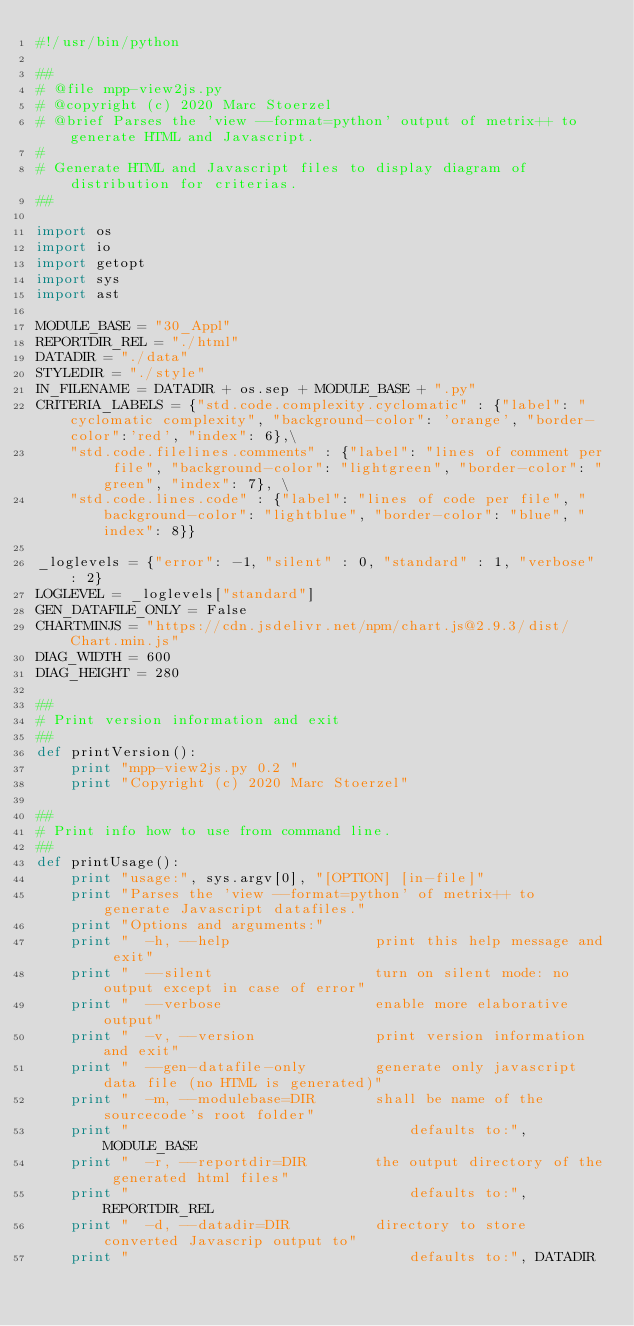Convert code to text. <code><loc_0><loc_0><loc_500><loc_500><_Python_>#!/usr/bin/python

##
# @file mpp-view2js.py
# @copyright (c) 2020 Marc Stoerzel
# @brief Parses the 'view --format=python' output of metrix++ to generate HTML and Javascript.
#
# Generate HTML and Javascript files to display diagram of distribution for criterias.
##

import os
import io
import getopt
import sys
import ast

MODULE_BASE = "30_Appl"
REPORTDIR_REL = "./html"
DATADIR = "./data"
STYLEDIR = "./style"
IN_FILENAME = DATADIR + os.sep + MODULE_BASE + ".py"
CRITERIA_LABELS = {"std.code.complexity.cyclomatic" : {"label": "cyclomatic complexity", "background-color": 'orange', "border-color":'red', "index": 6},\
    "std.code.filelines.comments" : {"label": "lines of comment per file", "background-color": "lightgreen", "border-color": "green", "index": 7}, \
    "std.code.lines.code" : {"label": "lines of code per file", "background-color": "lightblue", "border-color": "blue", "index": 8}}

_loglevels = {"error": -1, "silent" : 0, "standard" : 1, "verbose" : 2}
LOGLEVEL = _loglevels["standard"]
GEN_DATAFILE_ONLY = False
CHARTMINJS = "https://cdn.jsdelivr.net/npm/chart.js@2.9.3/dist/Chart.min.js"
DIAG_WIDTH = 600
DIAG_HEIGHT = 280

##
# Print version information and exit
##
def printVersion():
    print "mpp-view2js.py 0.2 "
    print "Copyright (c) 2020 Marc Stoerzel"

##
# Print info how to use from command line.
##
def printUsage():
    print "usage:", sys.argv[0], "[OPTION] [in-file]"
    print "Parses the 'view --format=python' of metrix++ to generate Javascript datafiles."
    print "Options and arguments:"
    print "  -h, --help                 print this help message and exit"
    print "  --silent                   turn on silent mode: no output except in case of error"
    print "  --verbose                  enable more elaborative output"
    print "  -v, --version              print version information and exit"
    print "  --gen-datafile-only        generate only javascript data file (no HTML is generated)"
    print "  -m, --modulebase=DIR       shall be name of the sourcecode's root folder"
    print "                                 defaults to:", MODULE_BASE
    print "  -r, --reportdir=DIR        the output directory of the generated html files"
    print "                                 defaults to:", REPORTDIR_REL
    print "  -d, --datadir=DIR          directory to store converted Javascrip output to"
    print "                                 defaults to:", DATADIR</code> 